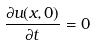<formula> <loc_0><loc_0><loc_500><loc_500>\frac { \partial u ( x , 0 ) } { \partial t } = 0</formula> 